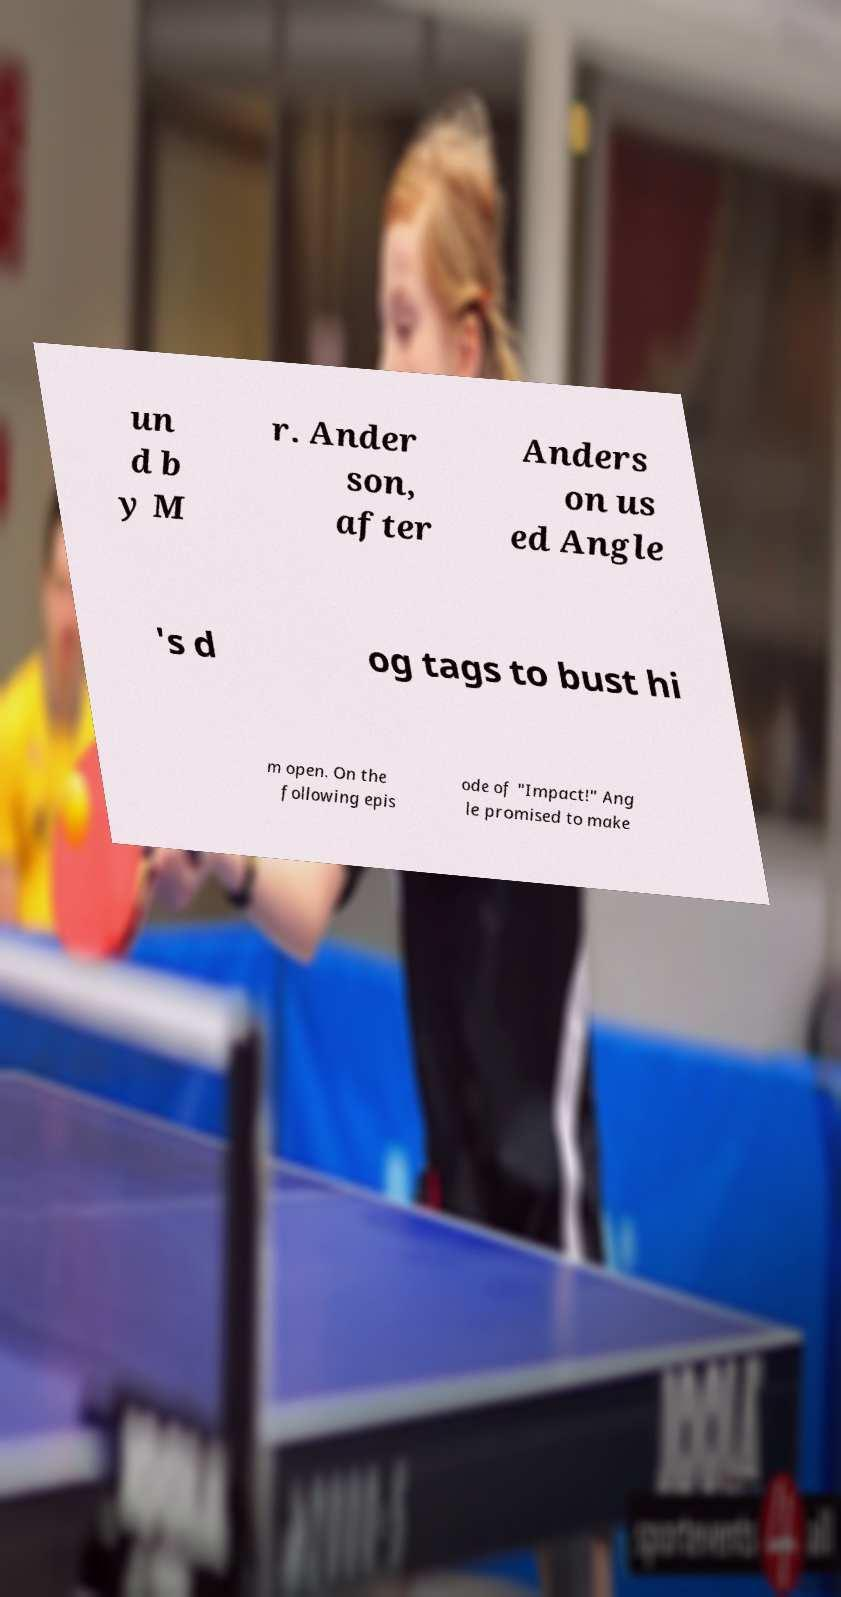Can you read and provide the text displayed in the image?This photo seems to have some interesting text. Can you extract and type it out for me? un d b y M r. Ander son, after Anders on us ed Angle 's d og tags to bust hi m open. On the following epis ode of "Impact!" Ang le promised to make 